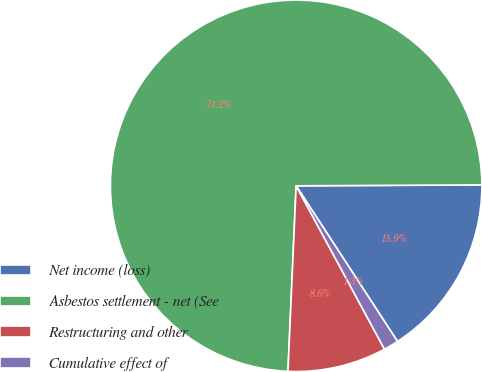<chart> <loc_0><loc_0><loc_500><loc_500><pie_chart><fcel>Net income (loss)<fcel>Asbestos settlement - net (See<fcel>Restructuring and other<fcel>Cumulative effect of<nl><fcel>15.89%<fcel>74.22%<fcel>8.59%<fcel>1.3%<nl></chart> 